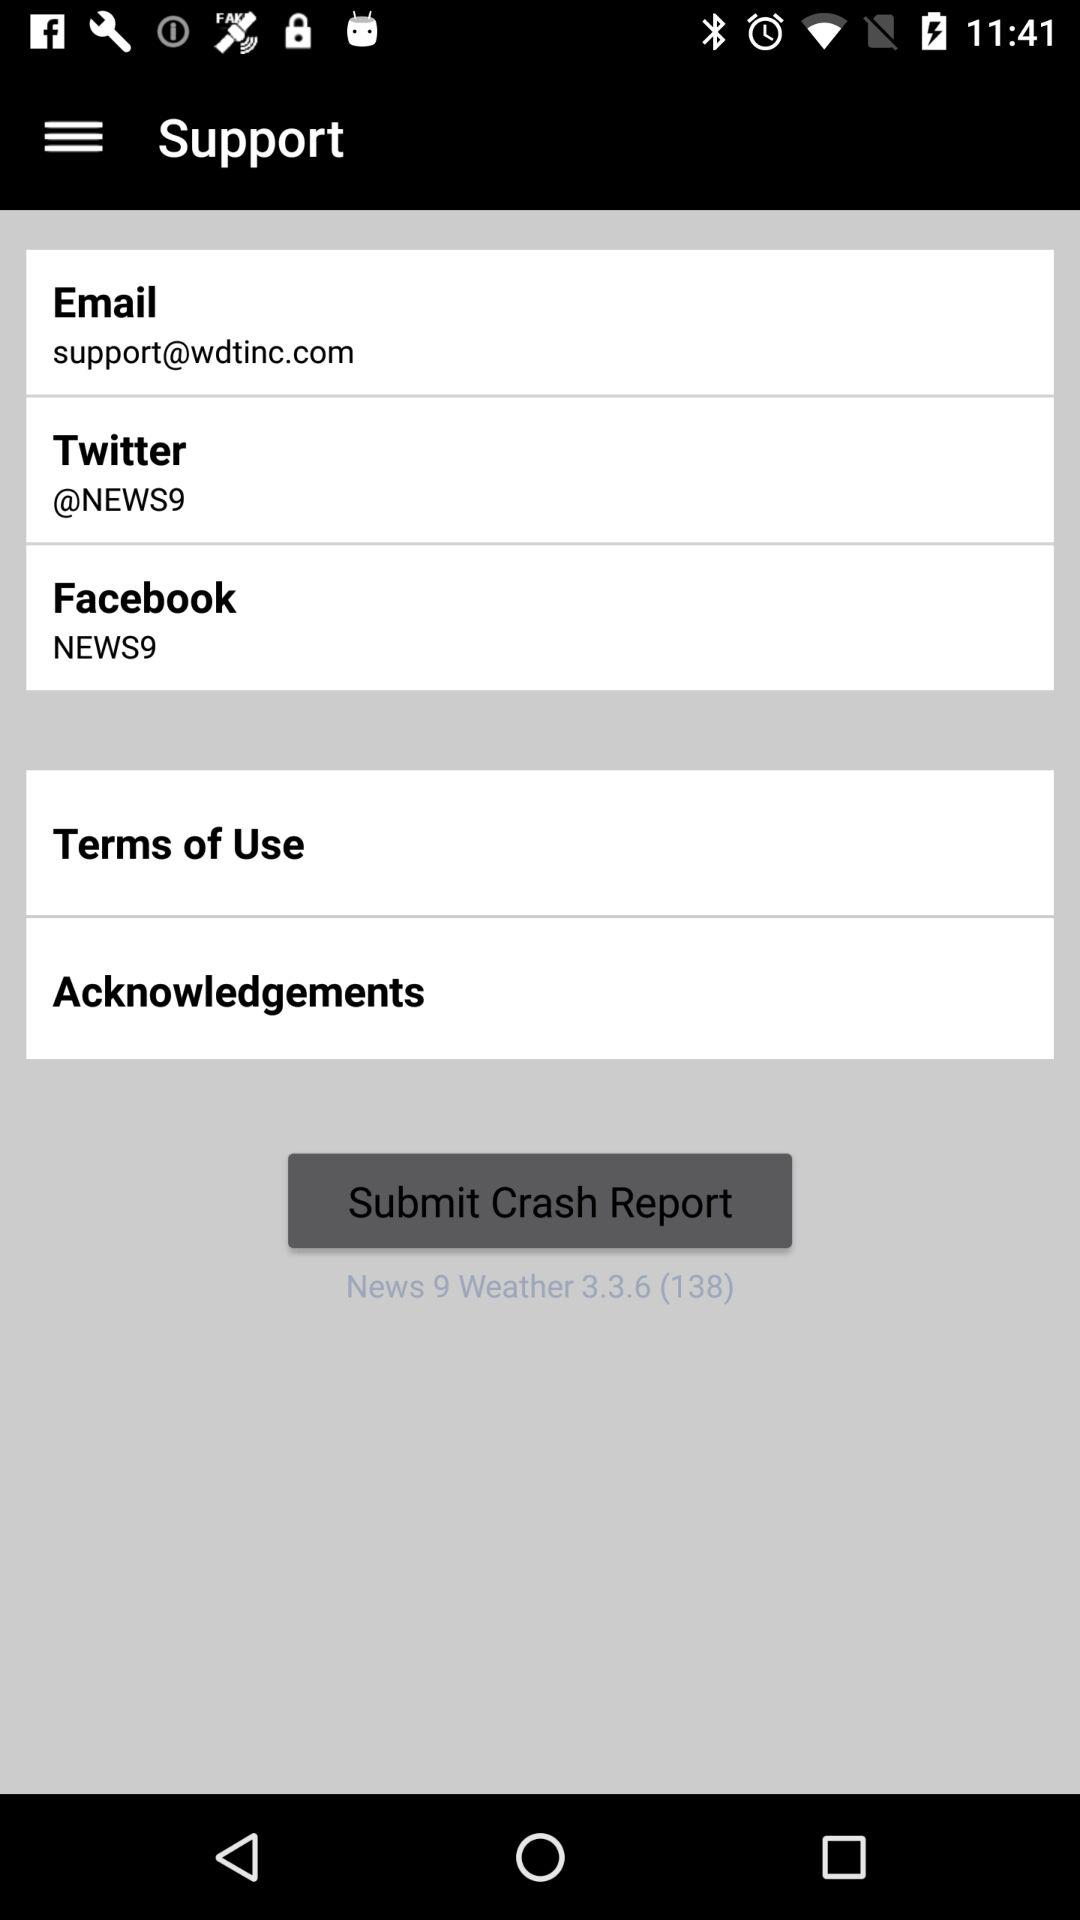What is the email address? The email address is "support@wdtinc.com". 